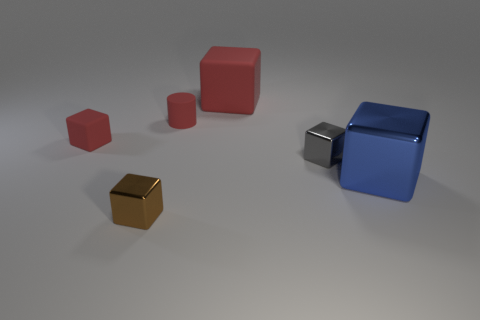Subtract all brown cubes. How many cubes are left? 4 Subtract all large blocks. How many blocks are left? 3 Subtract 1 cubes. How many cubes are left? 4 Add 1 shiny cylinders. How many objects exist? 7 Subtract all green cubes. Subtract all cyan cylinders. How many cubes are left? 5 Subtract all blocks. How many objects are left? 1 Subtract all blocks. Subtract all small green things. How many objects are left? 1 Add 4 blue objects. How many blue objects are left? 5 Add 6 tiny red metal cylinders. How many tiny red metal cylinders exist? 6 Subtract 0 cyan cubes. How many objects are left? 6 